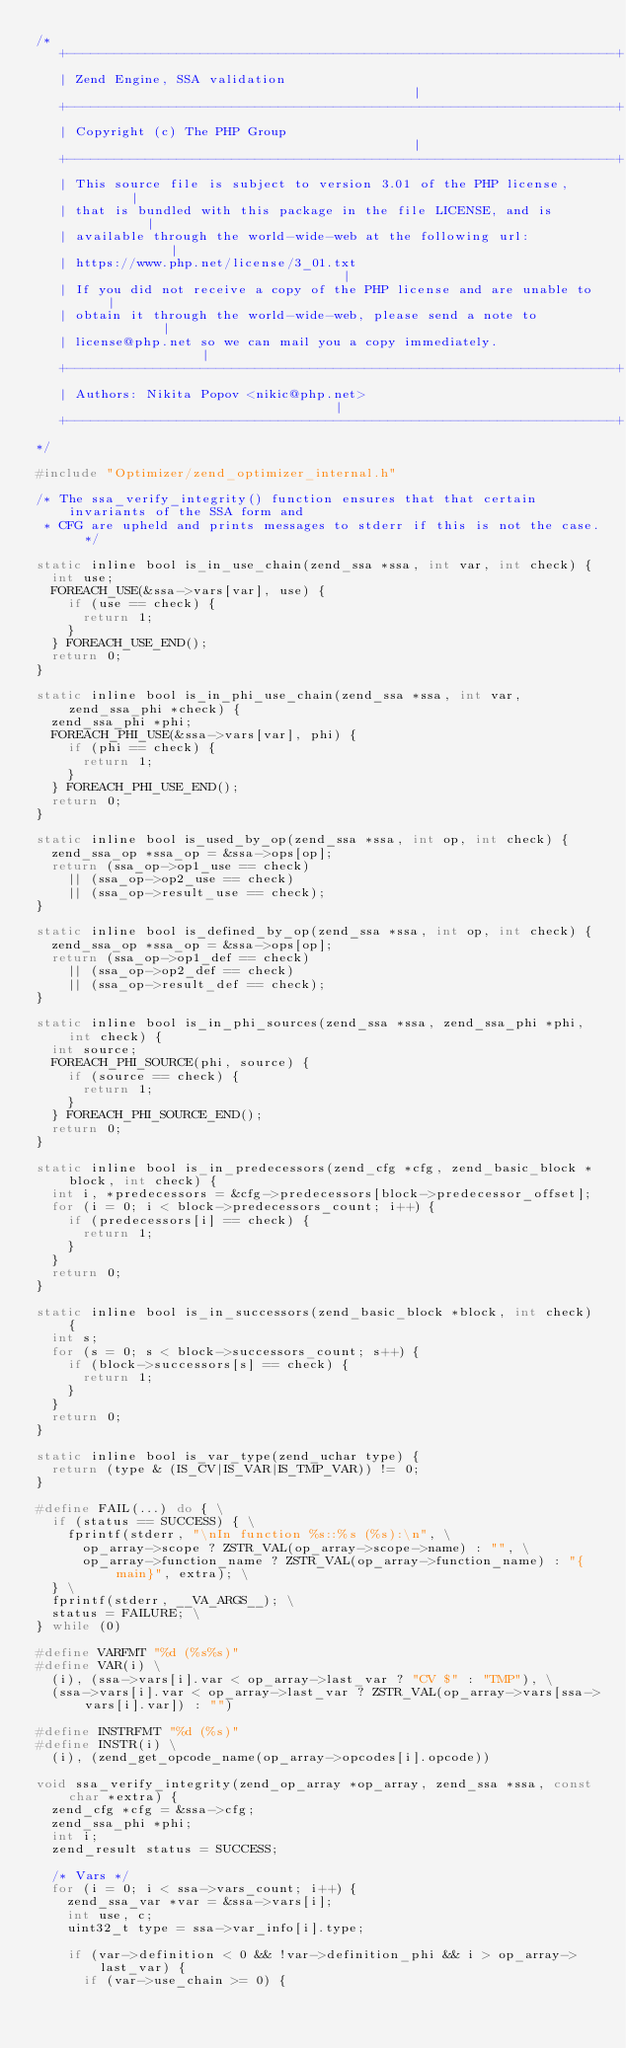Convert code to text. <code><loc_0><loc_0><loc_500><loc_500><_C_>/*
   +----------------------------------------------------------------------+
   | Zend Engine, SSA validation                                          |
   +----------------------------------------------------------------------+
   | Copyright (c) The PHP Group                                          |
   +----------------------------------------------------------------------+
   | This source file is subject to version 3.01 of the PHP license,      |
   | that is bundled with this package in the file LICENSE, and is        |
   | available through the world-wide-web at the following url:           |
   | https://www.php.net/license/3_01.txt                                 |
   | If you did not receive a copy of the PHP license and are unable to   |
   | obtain it through the world-wide-web, please send a note to          |
   | license@php.net so we can mail you a copy immediately.               |
   +----------------------------------------------------------------------+
   | Authors: Nikita Popov <nikic@php.net>                                |
   +----------------------------------------------------------------------+
*/

#include "Optimizer/zend_optimizer_internal.h"

/* The ssa_verify_integrity() function ensures that that certain invariants of the SSA form and
 * CFG are upheld and prints messages to stderr if this is not the case. */

static inline bool is_in_use_chain(zend_ssa *ssa, int var, int check) {
	int use;
	FOREACH_USE(&ssa->vars[var], use) {
		if (use == check) {
			return 1;
		}
	} FOREACH_USE_END();
	return 0;
}

static inline bool is_in_phi_use_chain(zend_ssa *ssa, int var, zend_ssa_phi *check) {
	zend_ssa_phi *phi;
	FOREACH_PHI_USE(&ssa->vars[var], phi) {
		if (phi == check) {
			return 1;
		}
	} FOREACH_PHI_USE_END();
	return 0;
}

static inline bool is_used_by_op(zend_ssa *ssa, int op, int check) {
	zend_ssa_op *ssa_op = &ssa->ops[op];
	return (ssa_op->op1_use == check)
		|| (ssa_op->op2_use == check)
		|| (ssa_op->result_use == check);
}

static inline bool is_defined_by_op(zend_ssa *ssa, int op, int check) {
	zend_ssa_op *ssa_op = &ssa->ops[op];
	return (ssa_op->op1_def == check)
		|| (ssa_op->op2_def == check)
		|| (ssa_op->result_def == check);
}

static inline bool is_in_phi_sources(zend_ssa *ssa, zend_ssa_phi *phi, int check) {
	int source;
	FOREACH_PHI_SOURCE(phi, source) {
		if (source == check) {
			return 1;
		}
	} FOREACH_PHI_SOURCE_END();
	return 0;
}

static inline bool is_in_predecessors(zend_cfg *cfg, zend_basic_block *block, int check) {
	int i, *predecessors = &cfg->predecessors[block->predecessor_offset];
	for (i = 0; i < block->predecessors_count; i++) {
		if (predecessors[i] == check) {
			return 1;
		}
	}
	return 0;
}

static inline bool is_in_successors(zend_basic_block *block, int check) {
	int s;
	for (s = 0; s < block->successors_count; s++) {
		if (block->successors[s] == check) {
			return 1;
		}
	}
	return 0;
}

static inline bool is_var_type(zend_uchar type) {
	return (type & (IS_CV|IS_VAR|IS_TMP_VAR)) != 0;
}

#define FAIL(...) do { \
	if (status == SUCCESS) { \
		fprintf(stderr, "\nIn function %s::%s (%s):\n", \
			op_array->scope ? ZSTR_VAL(op_array->scope->name) : "", \
			op_array->function_name ? ZSTR_VAL(op_array->function_name) : "{main}", extra); \
	} \
	fprintf(stderr, __VA_ARGS__); \
	status = FAILURE; \
} while (0)

#define VARFMT "%d (%s%s)"
#define VAR(i) \
	(i), (ssa->vars[i].var < op_array->last_var ? "CV $" : "TMP"), \
	(ssa->vars[i].var < op_array->last_var ? ZSTR_VAL(op_array->vars[ssa->vars[i].var]) : "")

#define INSTRFMT "%d (%s)"
#define INSTR(i) \
	(i), (zend_get_opcode_name(op_array->opcodes[i].opcode))

void ssa_verify_integrity(zend_op_array *op_array, zend_ssa *ssa, const char *extra) {
	zend_cfg *cfg = &ssa->cfg;
	zend_ssa_phi *phi;
	int i;
	zend_result status = SUCCESS;

	/* Vars */
	for (i = 0; i < ssa->vars_count; i++) {
		zend_ssa_var *var = &ssa->vars[i];
		int use, c;
		uint32_t type = ssa->var_info[i].type;

		if (var->definition < 0 && !var->definition_phi && i > op_array->last_var) {
			if (var->use_chain >= 0) {</code> 